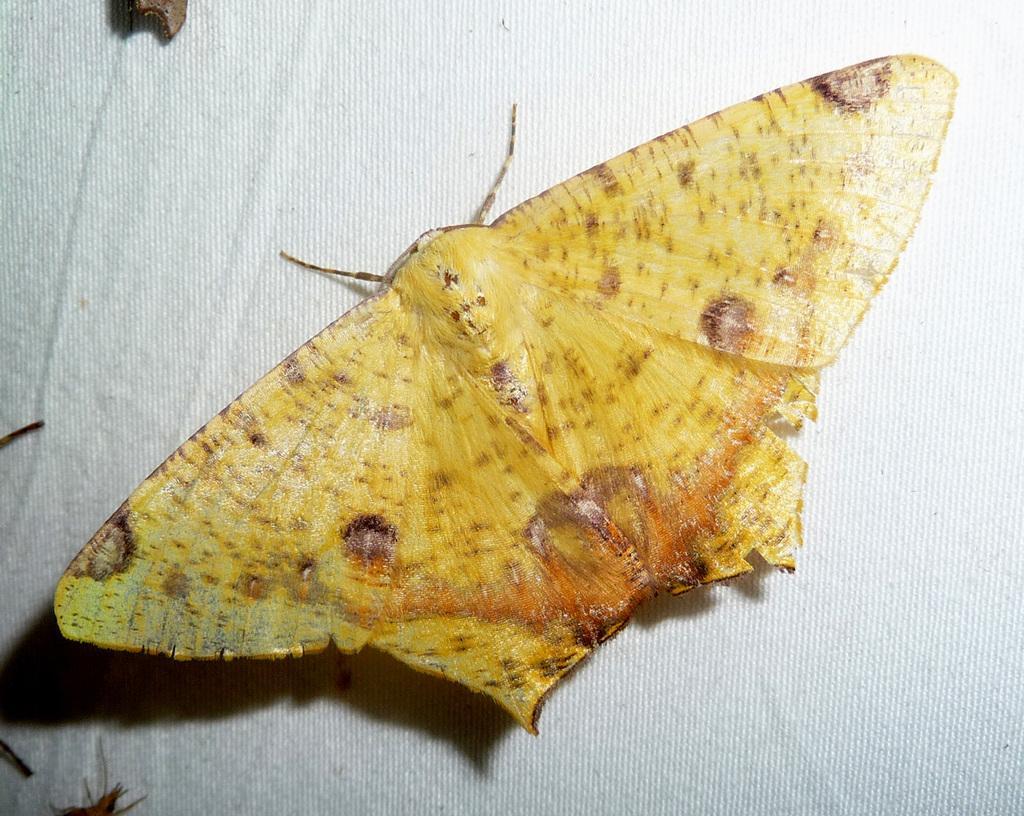Can you describe this image briefly? In this image, we can see an insect on the white cloth. 